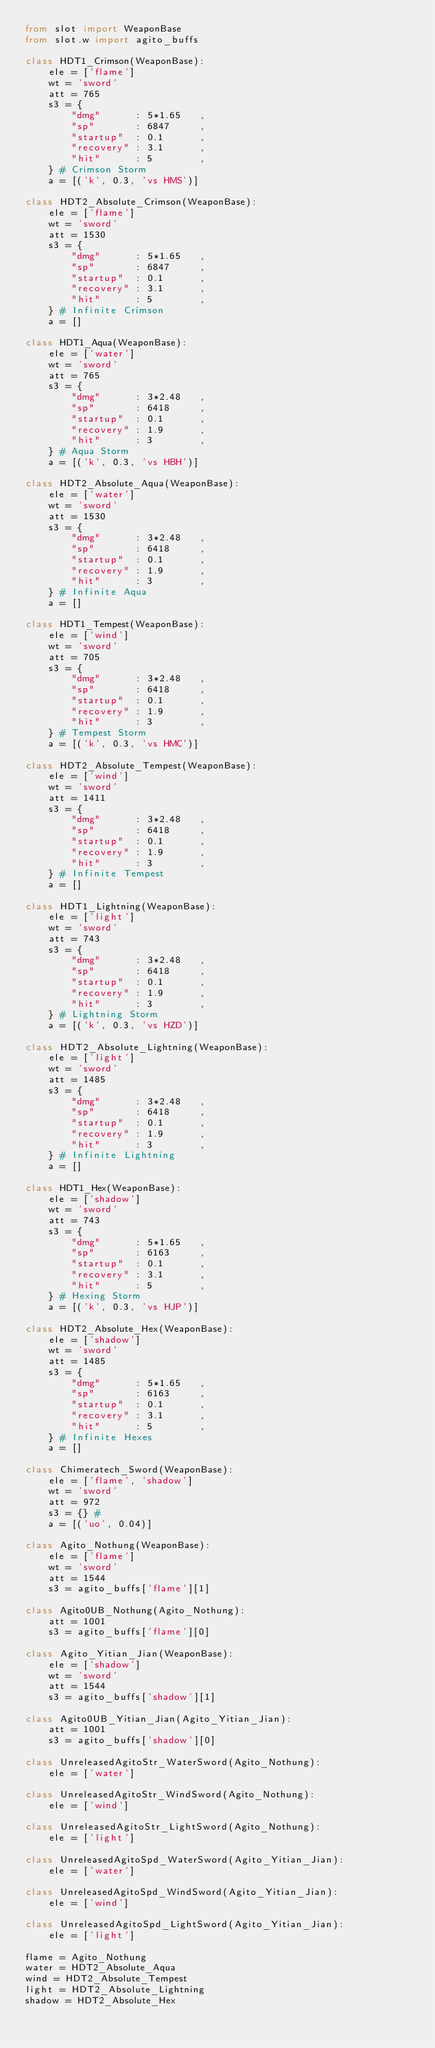<code> <loc_0><loc_0><loc_500><loc_500><_Python_>from slot import WeaponBase
from slot.w import agito_buffs

class HDT1_Crimson(WeaponBase):
    ele = ['flame']
    wt = 'sword'
    att = 765
    s3 = {
        "dmg"      : 5*1.65   ,
        "sp"       : 6847     ,
        "startup"  : 0.1      ,
        "recovery" : 3.1      ,
        "hit"      : 5        ,
    } # Crimson Storm
    a = [('k', 0.3, 'vs HMS')]

class HDT2_Absolute_Crimson(WeaponBase):
    ele = ['flame']
    wt = 'sword'
    att = 1530
    s3 = {
        "dmg"      : 5*1.65   ,
        "sp"       : 6847     ,
        "startup"  : 0.1      ,
        "recovery" : 3.1      ,
        "hit"      : 5        ,
    } # Infinite Crimson
    a = []

class HDT1_Aqua(WeaponBase):
    ele = ['water']
    wt = 'sword'
    att = 765
    s3 = {
        "dmg"      : 3*2.48   ,
        "sp"       : 6418     ,
        "startup"  : 0.1      ,
        "recovery" : 1.9      ,
        "hit"      : 3        ,
    } # Aqua Storm
    a = [('k', 0.3, 'vs HBH')]

class HDT2_Absolute_Aqua(WeaponBase):
    ele = ['water']
    wt = 'sword'
    att = 1530
    s3 = {
        "dmg"      : 3*2.48   ,
        "sp"       : 6418     ,
        "startup"  : 0.1      ,
        "recovery" : 1.9      ,
        "hit"      : 3        ,
    } # Infinite Aqua
    a = []

class HDT1_Tempest(WeaponBase):
    ele = ['wind']
    wt = 'sword'
    att = 705
    s3 = {
        "dmg"      : 3*2.48   ,
        "sp"       : 6418     ,
        "startup"  : 0.1      ,
        "recovery" : 1.9      ,
        "hit"      : 3        ,
    } # Tempest Storm
    a = [('k', 0.3, 'vs HMC')]

class HDT2_Absolute_Tempest(WeaponBase):
    ele = ['wind']
    wt = 'sword'
    att = 1411
    s3 = {
        "dmg"      : 3*2.48   ,
        "sp"       : 6418     ,
        "startup"  : 0.1      ,
        "recovery" : 1.9      ,
        "hit"      : 3        ,
    } # Infinite Tempest
    a = []

class HDT1_Lightning(WeaponBase):
    ele = ['light']
    wt = 'sword'
    att = 743
    s3 = {
        "dmg"      : 3*2.48   ,
        "sp"       : 6418     ,
        "startup"  : 0.1      ,
        "recovery" : 1.9      ,
        "hit"      : 3        ,
    } # Lightning Storm
    a = [('k', 0.3, 'vs HZD')]

class HDT2_Absolute_Lightning(WeaponBase):
    ele = ['light']
    wt = 'sword'
    att = 1485
    s3 = {
        "dmg"      : 3*2.48   ,
        "sp"       : 6418     ,
        "startup"  : 0.1      ,
        "recovery" : 1.9      ,
        "hit"      : 3        ,
    } # Infinite Lightning
    a = []

class HDT1_Hex(WeaponBase):
    ele = ['shadow']
    wt = 'sword'
    att = 743
    s3 = {
        "dmg"      : 5*1.65   ,
        "sp"       : 6163     ,
        "startup"  : 0.1      ,
        "recovery" : 3.1      ,
        "hit"      : 5        ,
    } # Hexing Storm
    a = [('k', 0.3, 'vs HJP')]

class HDT2_Absolute_Hex(WeaponBase):
    ele = ['shadow']
    wt = 'sword'
    att = 1485
    s3 = {
        "dmg"      : 5*1.65   ,
        "sp"       : 6163     ,
        "startup"  : 0.1      ,
        "recovery" : 3.1      ,
        "hit"      : 5        ,
    } # Infinite Hexes
    a = []

class Chimeratech_Sword(WeaponBase):
    ele = ['flame', 'shadow']
    wt = 'sword'
    att = 972
    s3 = {} #
    a = [('uo', 0.04)]

class Agito_Nothung(WeaponBase):
    ele = ['flame']
    wt = 'sword'
    att = 1544
    s3 = agito_buffs['flame'][1]

class Agito0UB_Nothung(Agito_Nothung):
    att = 1001
    s3 = agito_buffs['flame'][0]

class Agito_Yitian_Jian(WeaponBase):
    ele = ['shadow']
    wt = 'sword'
    att = 1544
    s3 = agito_buffs['shadow'][1]

class Agito0UB_Yitian_Jian(Agito_Yitian_Jian):
    att = 1001
    s3 = agito_buffs['shadow'][0]

class UnreleasedAgitoStr_WaterSword(Agito_Nothung):
    ele = ['water']

class UnreleasedAgitoStr_WindSword(Agito_Nothung):
    ele = ['wind']

class UnreleasedAgitoStr_LightSword(Agito_Nothung):
    ele = ['light']

class UnreleasedAgitoSpd_WaterSword(Agito_Yitian_Jian):
    ele = ['water']

class UnreleasedAgitoSpd_WindSword(Agito_Yitian_Jian):
    ele = ['wind']

class UnreleasedAgitoSpd_LightSword(Agito_Yitian_Jian):
    ele = ['light']

flame = Agito_Nothung
water = HDT2_Absolute_Aqua
wind = HDT2_Absolute_Tempest
light = HDT2_Absolute_Lightning
shadow = HDT2_Absolute_Hex</code> 